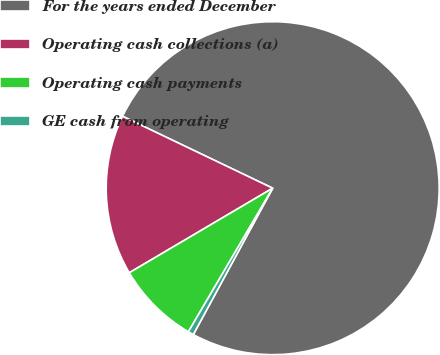Convert chart. <chart><loc_0><loc_0><loc_500><loc_500><pie_chart><fcel>For the years ended December<fcel>Operating cash collections (a)<fcel>Operating cash payments<fcel>GE cash from operating<nl><fcel>75.8%<fcel>15.59%<fcel>8.07%<fcel>0.54%<nl></chart> 